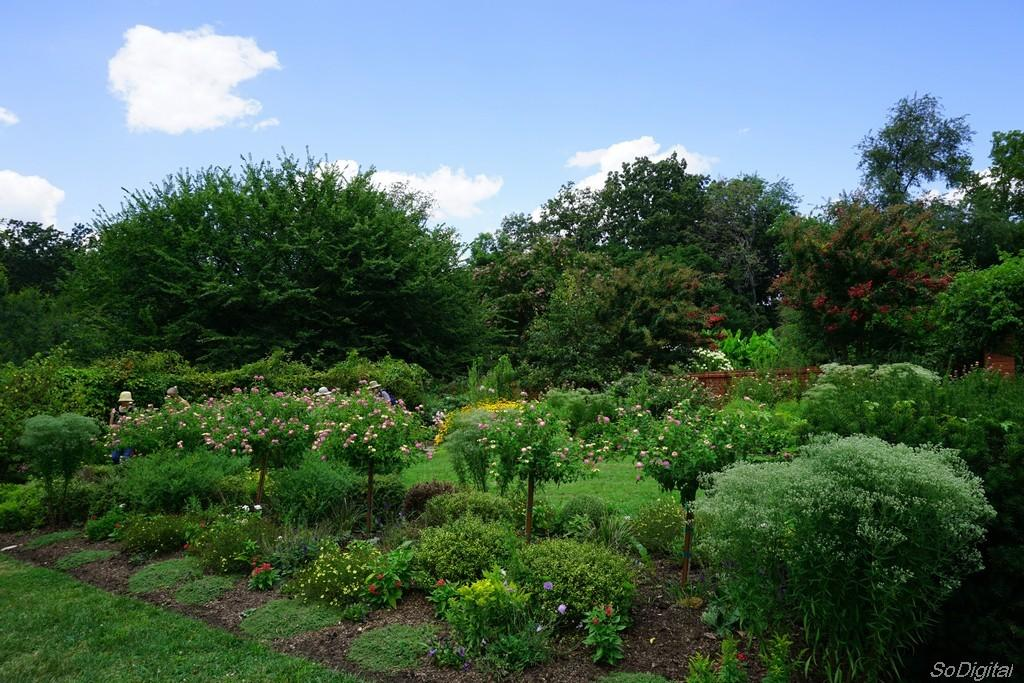How many people are in the image? There are persons in the image, but the exact number is not specified. What types of plants are in the image? There are plants, flowers, and trees in the image. What is visible in the background of the image? The sky is visible in the background of the image. Is there any indication of a watermark on the image? Yes, there is a watermark on the image. What type of battle is depicted in the image? There is no battle depicted in the image; it features persons, plants, and the sky. What color is the ink used for the watermark in the image? The watermark is not described in terms of color, and the color of the ink used is not specified. 